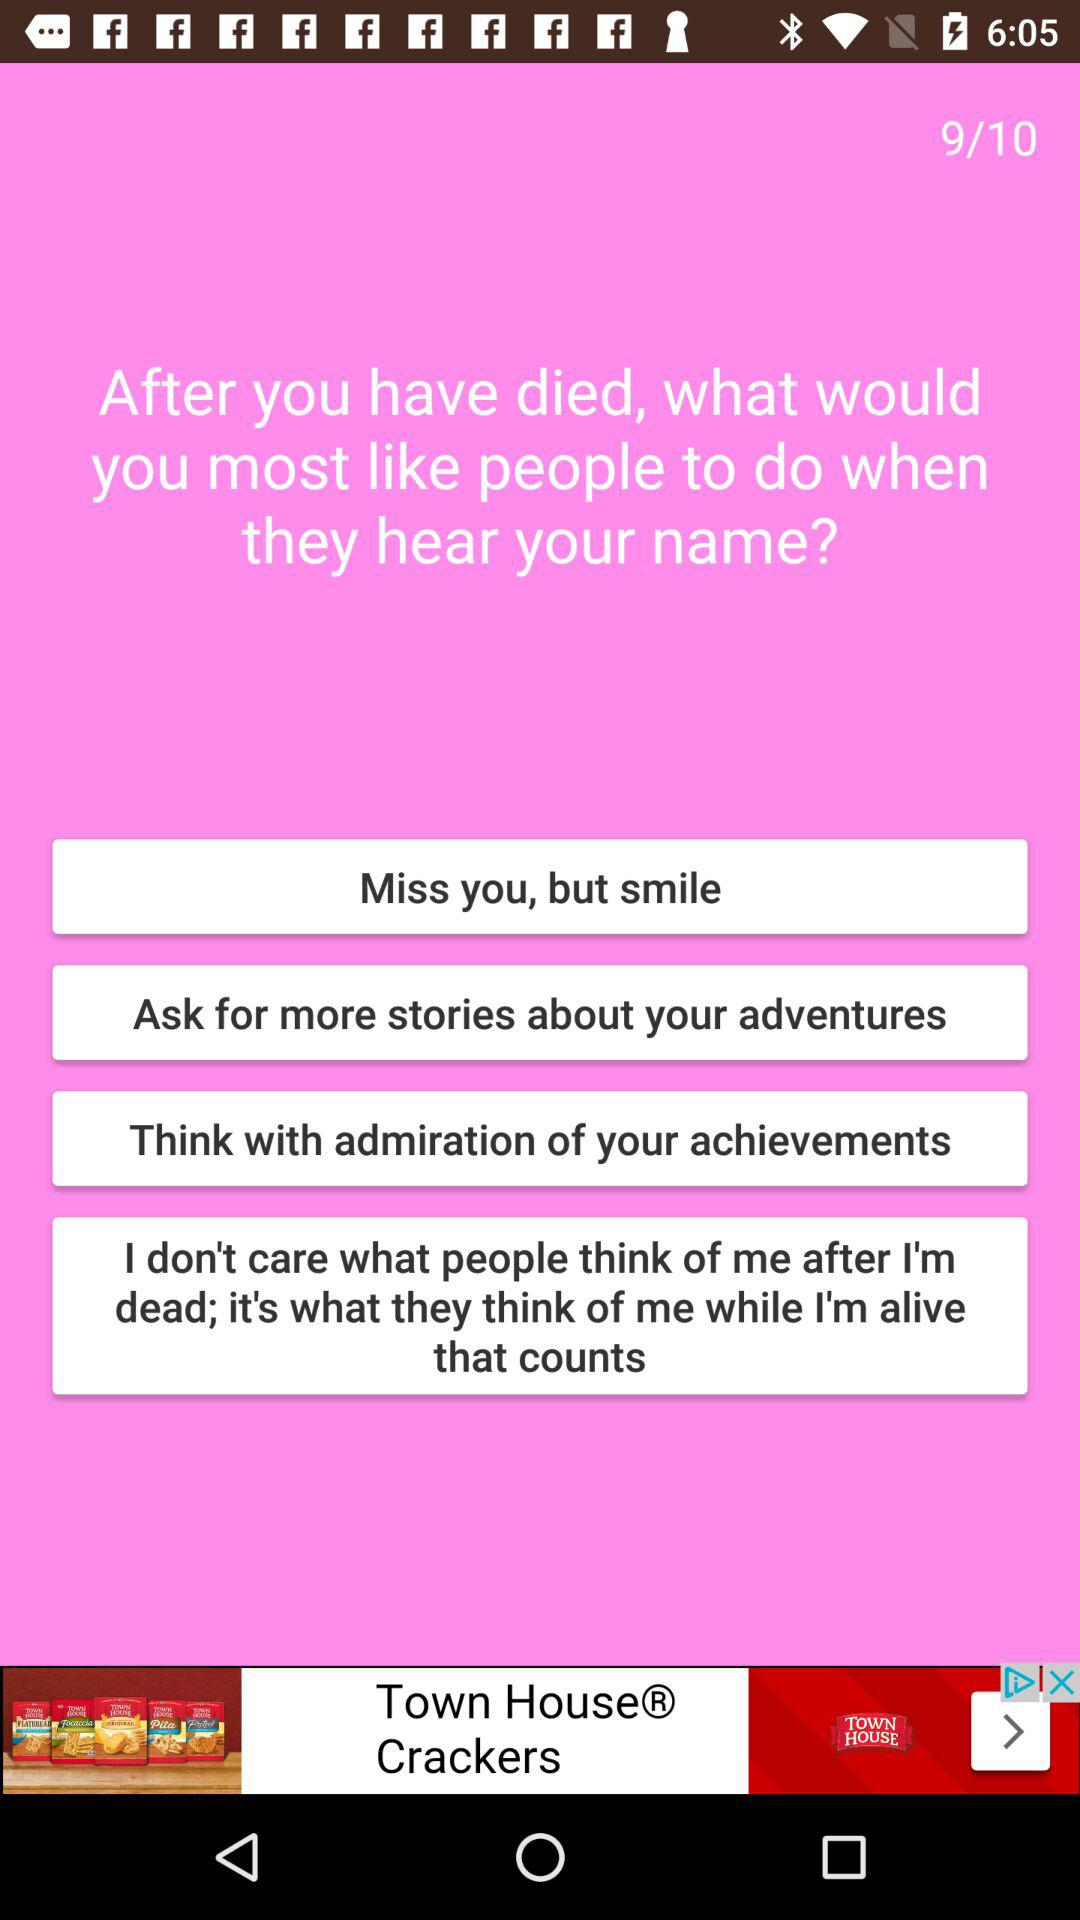What are the options for "when you die, what would you like to hear from people"? The options are: "Miss you, but smile", "Ask for more stories about your adventures", "Think with admiration of your achievements", and "I don't care what people think of me after I'm dead; it's what they think of me while I'm alive that counts". 